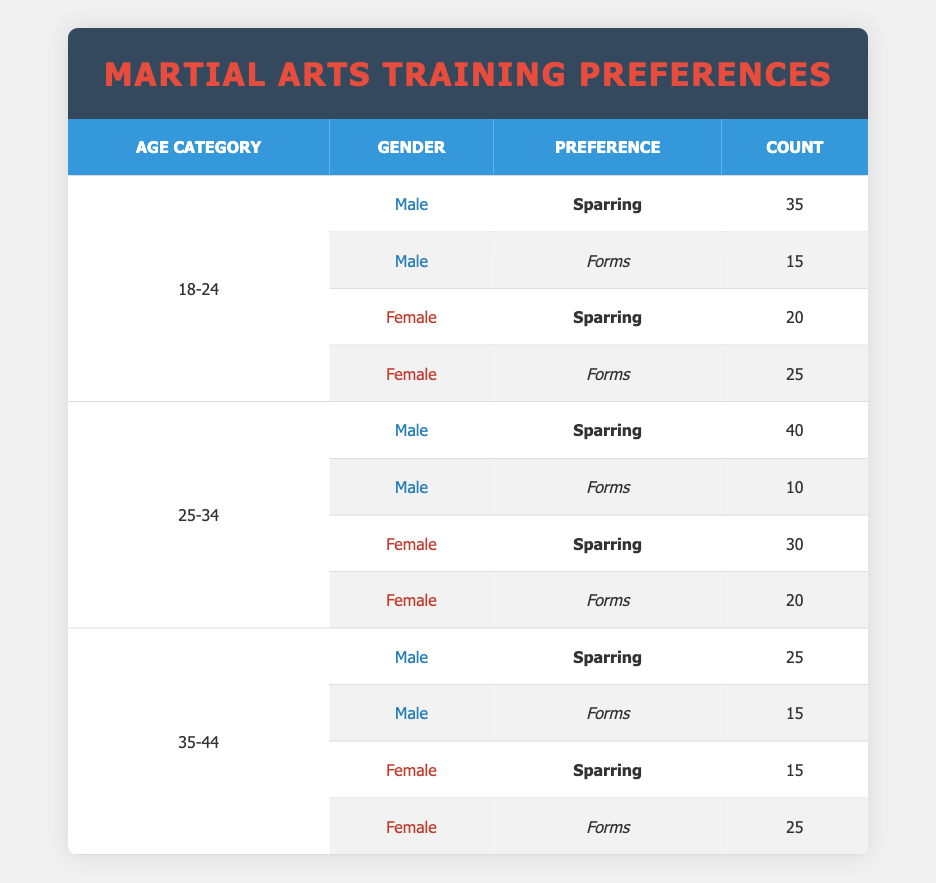What is the total count of males who prefer sparring? From the table, we identify the male preferences for sparring: 35 (ages 18-24) + 40 (ages 25-34) + 25 (ages 35-44) = 100. Thus, the total count of males who prefer sparring is 100.
Answer: 100 What is the preference of females in the age category 25-34? In the 25-34 age category, we have two preferences for females: sparring (30) and forms (20). Therefore, females in this age category prefer both sparring and forms, with sparring being higher.
Answer: Sparring and forms Is there any age category where males prefer forms over sparring? By analyzing the male preferences, we note that in the age categories 18-24, 25-34, and 35-44, males have counts of 15, 10, and 15 for forms respectively, while their sparring counts are 35, 40, and 25 respectively. Therefore, the answer is no, males do not prefer forms over sparring in any age category.
Answer: No What is the average count of females who prefer forms across all age categories? The counts of females who prefer forms are 25 (ages 18-24) + 20 (ages 25-34) + 25 (ages 35-44) = 70. There are 3 data points, hence the average is 70/3, which equals approximately 23.33.
Answer: 23.33 How many more males prefer sparring than females across all age categories combined? Adding the male preference for sparring gives 100, while adding the female preference for sparring results in 20 (ages 18-24) + 30 (ages 25-34) + 15 (ages 35-44) = 65. The difference is 100 - 65 = 35, indicating that 35 more males prefer sparring than females across all age categories.
Answer: 35 What percentage of the 18-24 age category prefers forms among males? In the age category of 18-24, the total count of males is 35 (sparring) + 15 (forms) = 50. The count for forms is 15, so the percentage is (15/50) * 100 = 30%.
Answer: 30% How many total participants are represented in the age category 35-44? In the age category of 35-44, we have the counts of males (25 + 15 = 40) and females (15 + 25 = 40). Therefore, the total participants in this category is 40 + 40 = 80.
Answer: 80 Is the number of females who prefer forms higher in the 18-24 or 35-44 age category? Reviewing the counts, females preferring forms in 18-24 age category is 25, while in the 35-44 age category it is also 25. Thus, both age categories have the same preference count for forms among females.
Answer: No, they are equal 